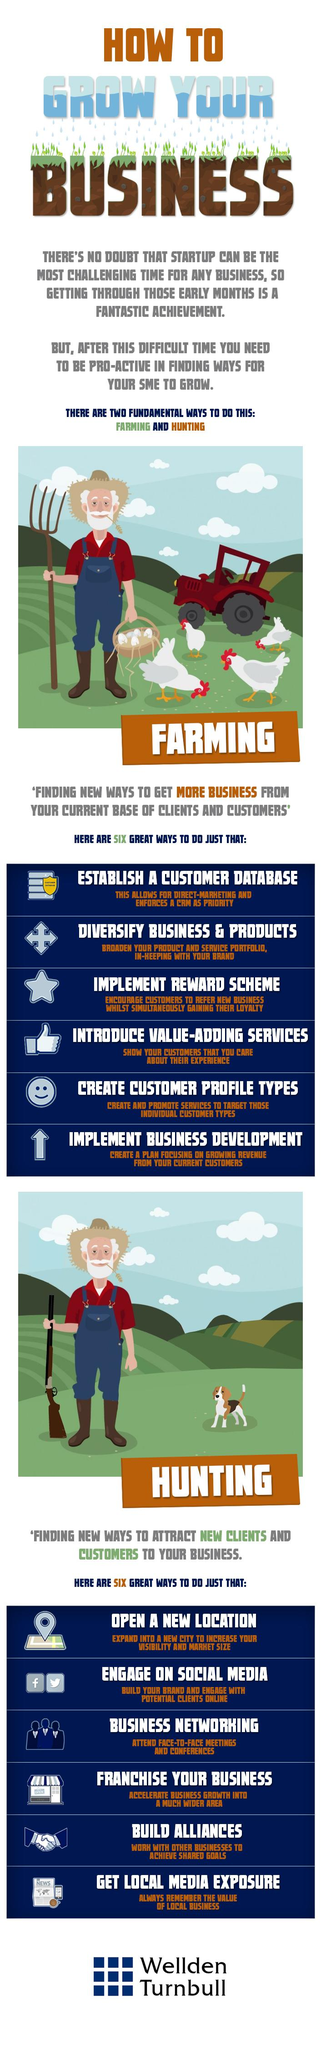Mention a couple of crucial points in this snapshot. Hunting" is one of the subtopics listed under the main topic of "Hunting in Wyoming," and the second point listed under this subtopic is "Engage on Social Media. The fifth point listed under "Farming" is "Use drip irrigation and mulching to conserve water and reduce erosion" and "Create Customer Profile Types" is a process of segmenting customers based on common characteristics to better understand and target specific groups. The best methods for achieving excellent growth in SMEs are farming and hunting. The third point listed under "Farming" is the implementation of a reward scheme. Franchising your business is the fourth point listed under the category of Hunting, which provides potential franchisees with the opportunity to own and operate their own Wild Boar Hunting business. 